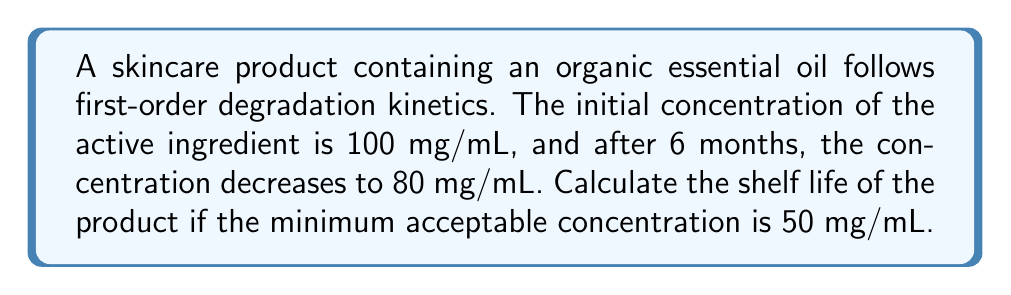What is the answer to this math problem? 1. First-order degradation kinetics follows the equation:
   $$ C(t) = C_0 e^{-kt} $$
   where $C(t)$ is the concentration at time $t$, $C_0$ is the initial concentration, and $k$ is the rate constant.

2. We can find the rate constant $k$ using the given information:
   $$ 80 = 100 e^{-k(6)} $$

3. Solving for $k$:
   $$ \ln(0.8) = -6k $$
   $$ k = -\frac{\ln(0.8)}{6} \approx 0.0372 \text{ month}^{-1} $$

4. Now, we can use this rate constant to find the time $t$ when the concentration reaches 50 mg/mL:
   $$ 50 = 100 e^{-0.0372t} $$

5. Solving for $t$:
   $$ \ln(0.5) = -0.0372t $$
   $$ t = -\frac{\ln(0.5)}{0.0372} \approx 18.64 \text{ months} $$

Therefore, the shelf life of the product is approximately 18.64 months.
Answer: 18.64 months 